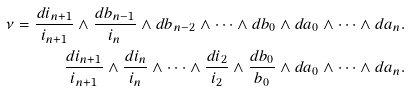Convert formula to latex. <formula><loc_0><loc_0><loc_500><loc_500>\nu = \frac { d i _ { n + 1 } } { i _ { n + 1 } } \wedge \frac { d b _ { n - 1 } } { i _ { n } } \wedge d b _ { n - 2 } \wedge \dots \wedge d b _ { 0 } \wedge d a _ { 0 } \wedge \dots \wedge d a _ { n } . \\ \frac { d i _ { n + 1 } } { i _ { n + 1 } } \wedge \frac { d i _ { n } } { i _ { n } } \wedge \dots \wedge \frac { d i _ { 2 } } { i _ { 2 } } \wedge \frac { d b _ { 0 } } { b _ { 0 } } \wedge d a _ { 0 } \wedge \dots \wedge d a _ { n } . \\</formula> 